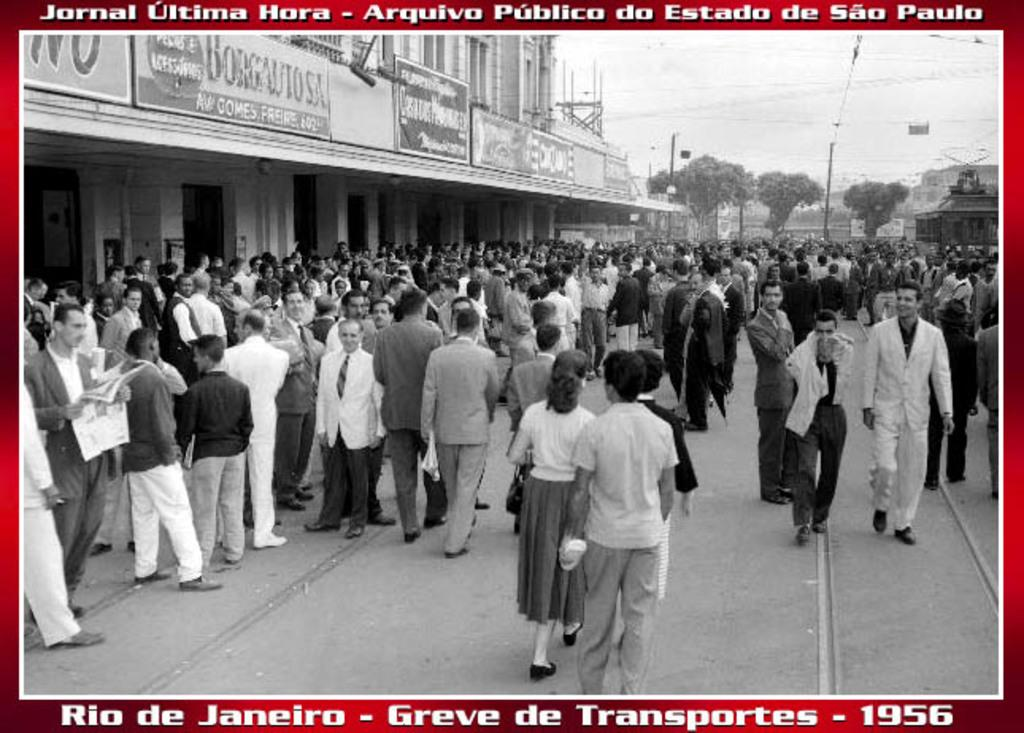<image>
Render a clear and concise summary of the photo. A postcard from Rio De Janeiro in 1956. 